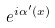<formula> <loc_0><loc_0><loc_500><loc_500>e ^ { i \alpha ^ { \prime } ( x ) }</formula> 